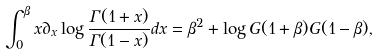Convert formula to latex. <formula><loc_0><loc_0><loc_500><loc_500>\int _ { 0 } ^ { \beta } x \partial _ { x } \log \frac { \Gamma ( 1 + x ) } { \Gamma ( 1 - x ) } d x = \beta ^ { 2 } + \log G ( 1 + \beta ) G ( 1 - \beta ) ,</formula> 